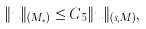Convert formula to latex. <formula><loc_0><loc_0><loc_500><loc_500>\| u \| _ { ( M _ { * } ) } \leq C _ { 5 } \| u \| _ { ( s , M ) } ,</formula> 